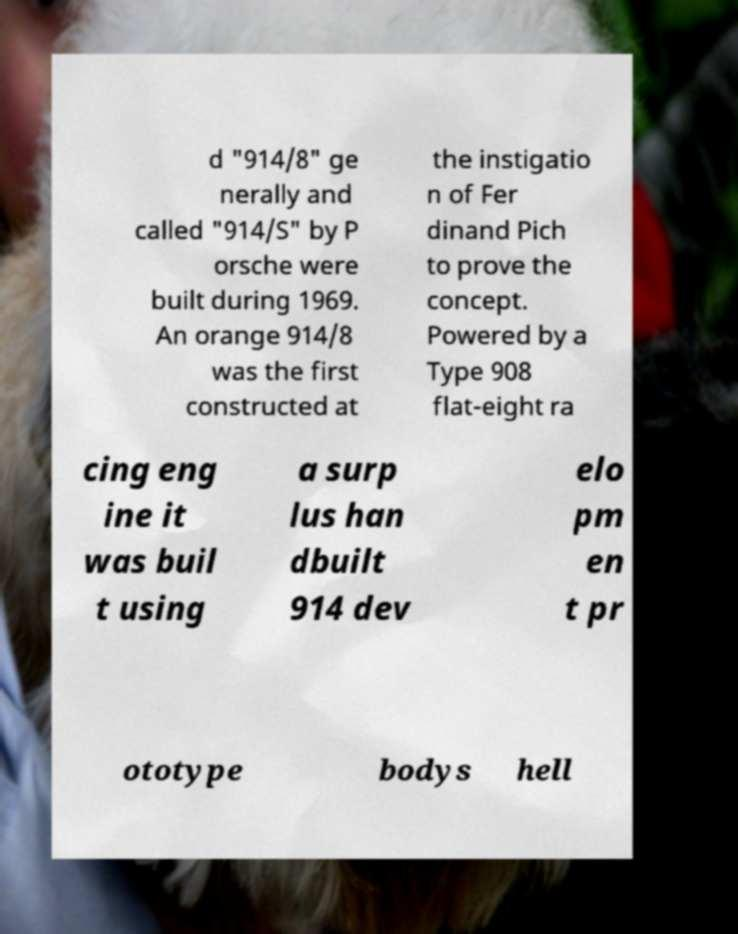Please read and relay the text visible in this image. What does it say? d "914/8" ge nerally and called "914/S" by P orsche were built during 1969. An orange 914/8 was the first constructed at the instigatio n of Fer dinand Pich to prove the concept. Powered by a Type 908 flat-eight ra cing eng ine it was buil t using a surp lus han dbuilt 914 dev elo pm en t pr ototype bodys hell 